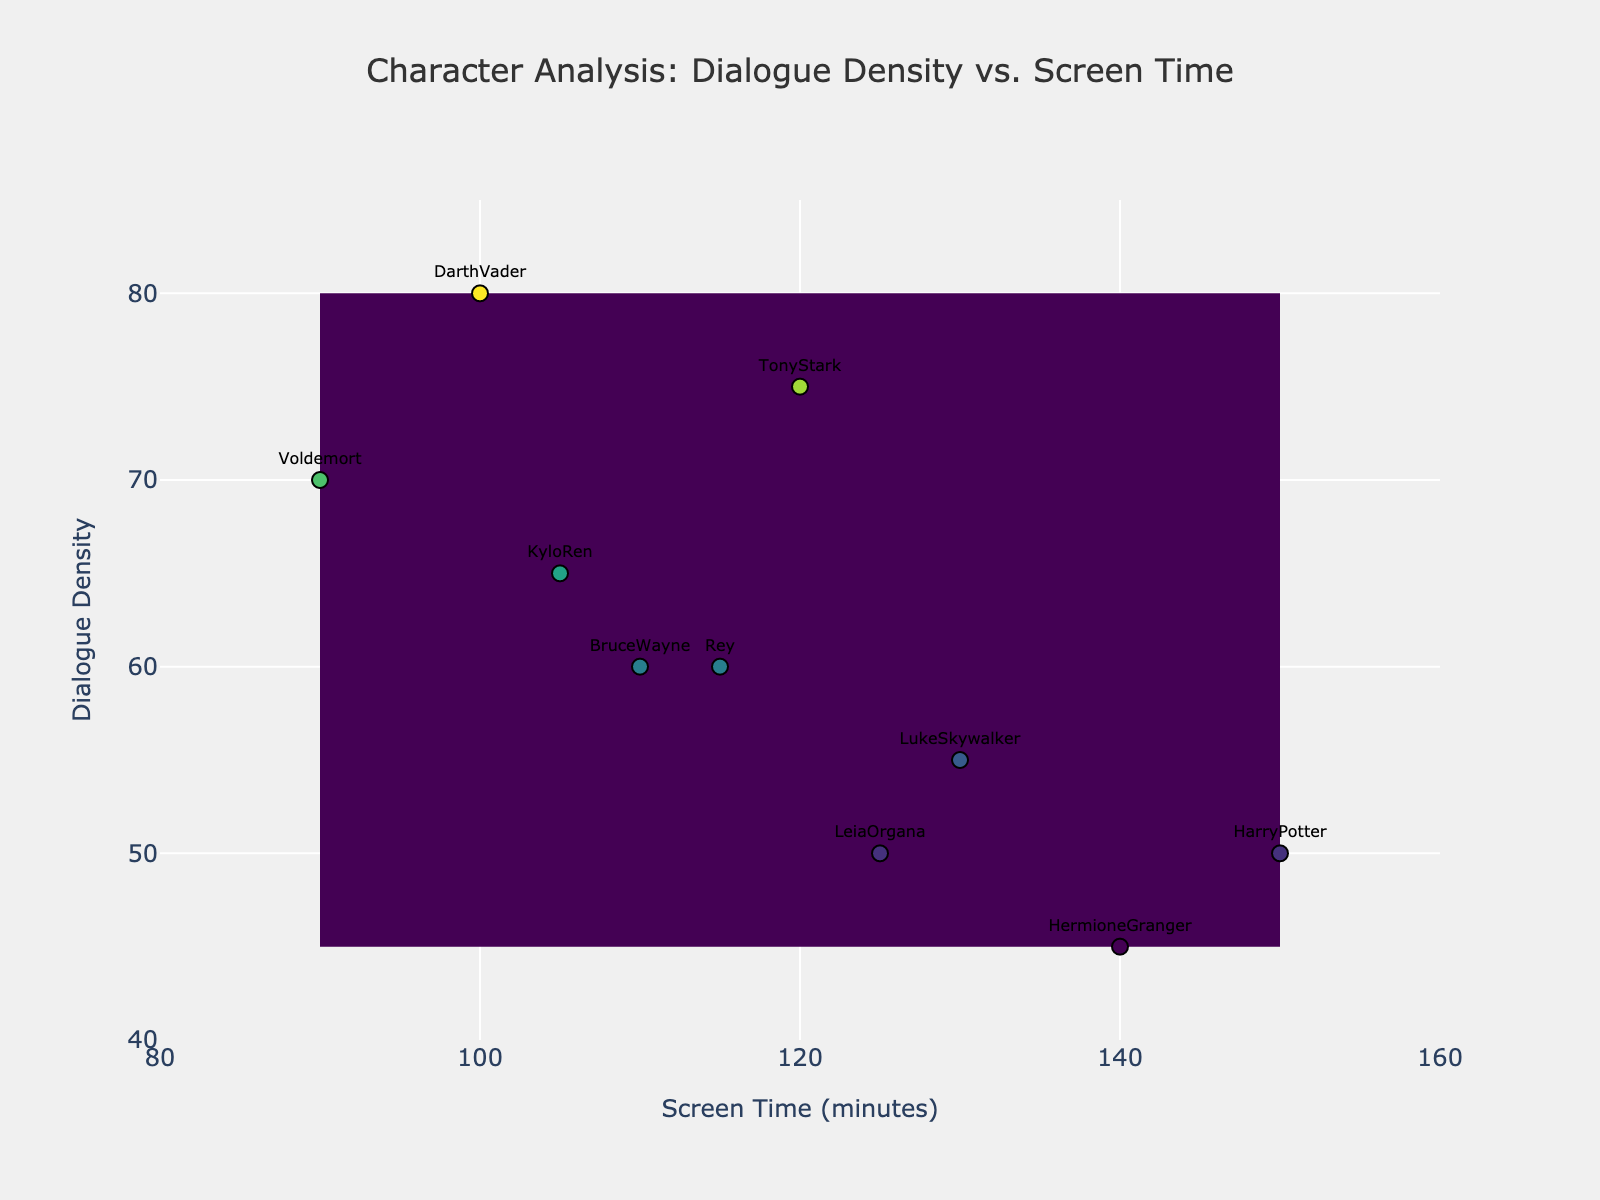What is the title of the figure? The title is usually positioned at the top of the figure and describes what the plot represents. In this case, the title indicates the relationship being analyzed.
Answer: Character Analysis: Dialogue Density vs. Screen Time What is the range of the x-axis (Screen Time)? The range of the x-axis can be determined by looking at the minimum and maximum values labeled on the axis. Here it shows values between 80 and 160 minutes.
Answer: 80 to 160 Which character has the highest dialogue density? By looking at the y-axis and identifying the highest point labeled with a character's name, we can find that Darth Vader appears at the highest dialogue density value.
Answer: Darth Vader How many characters have a dialogue density over 60? By identifying data points above the 60 mark on the y-axis and counting them, we see there are five characters: Tony Stark, Darth Vader, Voldemort, Kylo Ren, and Rey.
Answer: 5 What is the average screen time of characters with a dialogue density less than 55? We identify the screen times of Harry Potter, Hermione Granger, and Luke Skywalker (150, 140, 130) and calculate the average: (150 + 140 + 130) / 3 = 420 / 3 = 140.
Answer: 140 Who has the lowest screen time and what is it? By checking the x-axis for the smallest value and the corresponding label, Voldemort has the lowest screen time with 90 minutes.
Answer: Voldemort, 90 minutes Which antagonist has the least dialogue density? Antagonists here are considered Darth Vader, Voldemort, and Kylo Ren. Observing their y-axis values, Voldemort has the lowest dialogue density at 70.
Answer: Voldemort What trends can be observed between dialogue density and screen time for protagonists? By examining how many points are distributed and labeled as protagonists (Tony Stark, Bruce Wayne, Harry Potter, Hermione Granger, Luke Skywalker, Leia Organa, and Rey), we notice a general trend where characters with higher screen time usually have a lower dialogue density.
Answer: Higher screen time tends to lower dialogue density for protagonists How is Rey's dialogue density compared to Kylo Ren's? By checking their positions on the y-axis, we can see that Rey's dialogue density is 60 which is lower than Kylo Ren's 65.
Answer: Rey's is lower than Kylo Ren's 